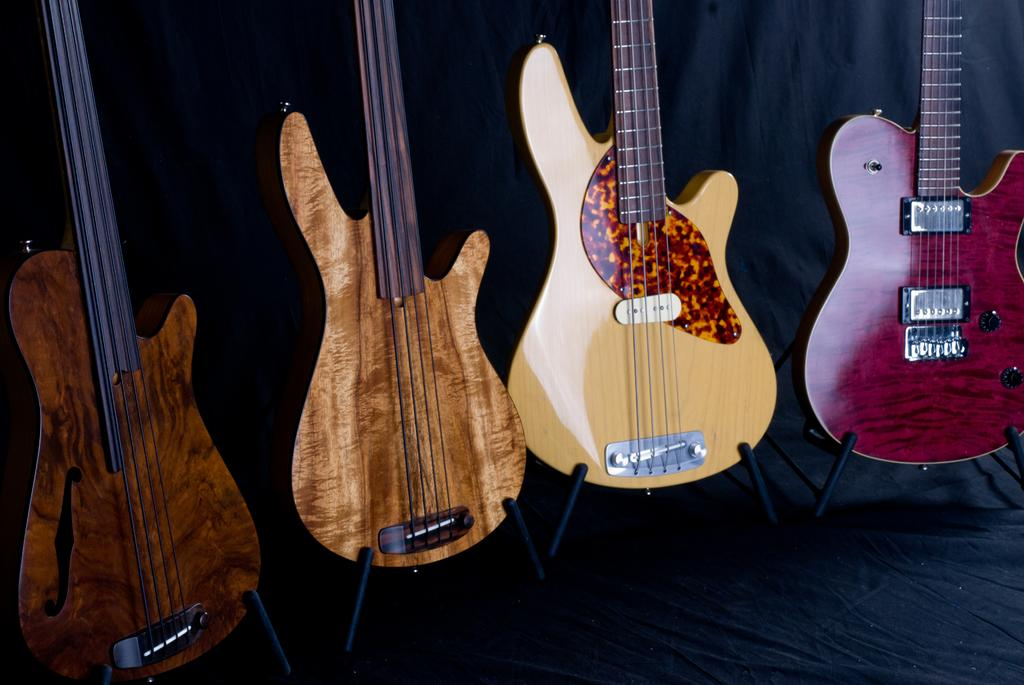How many guitars are present in the image? There are four guitars in the image. What is the name of the mother of the person who played the guitars in the image? There is no information about the person who played the guitars or their mother in the image, so this information cannot be determined. 